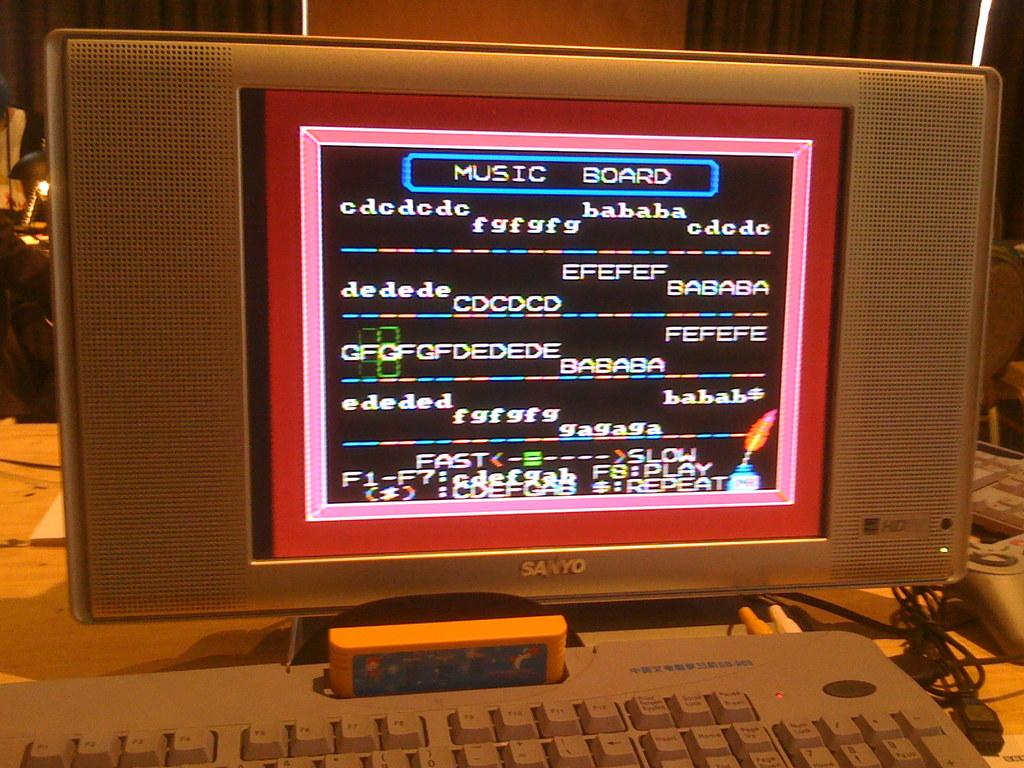<image>
Relay a brief, clear account of the picture shown. A sanyo computer showing a music board showing the letters of the notes 